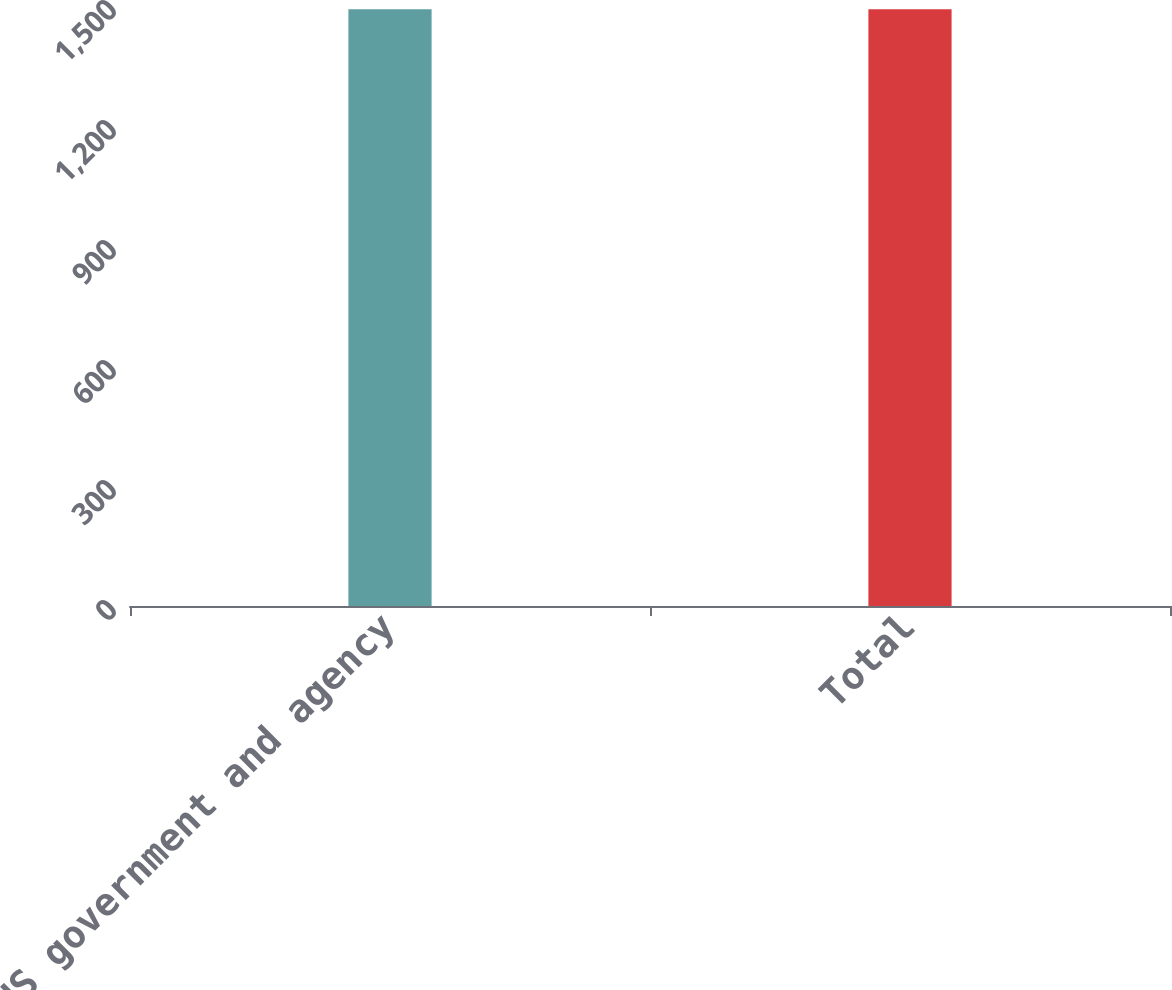Convert chart to OTSL. <chart><loc_0><loc_0><loc_500><loc_500><bar_chart><fcel>US government and agency<fcel>Total<nl><fcel>1492<fcel>1492.1<nl></chart> 